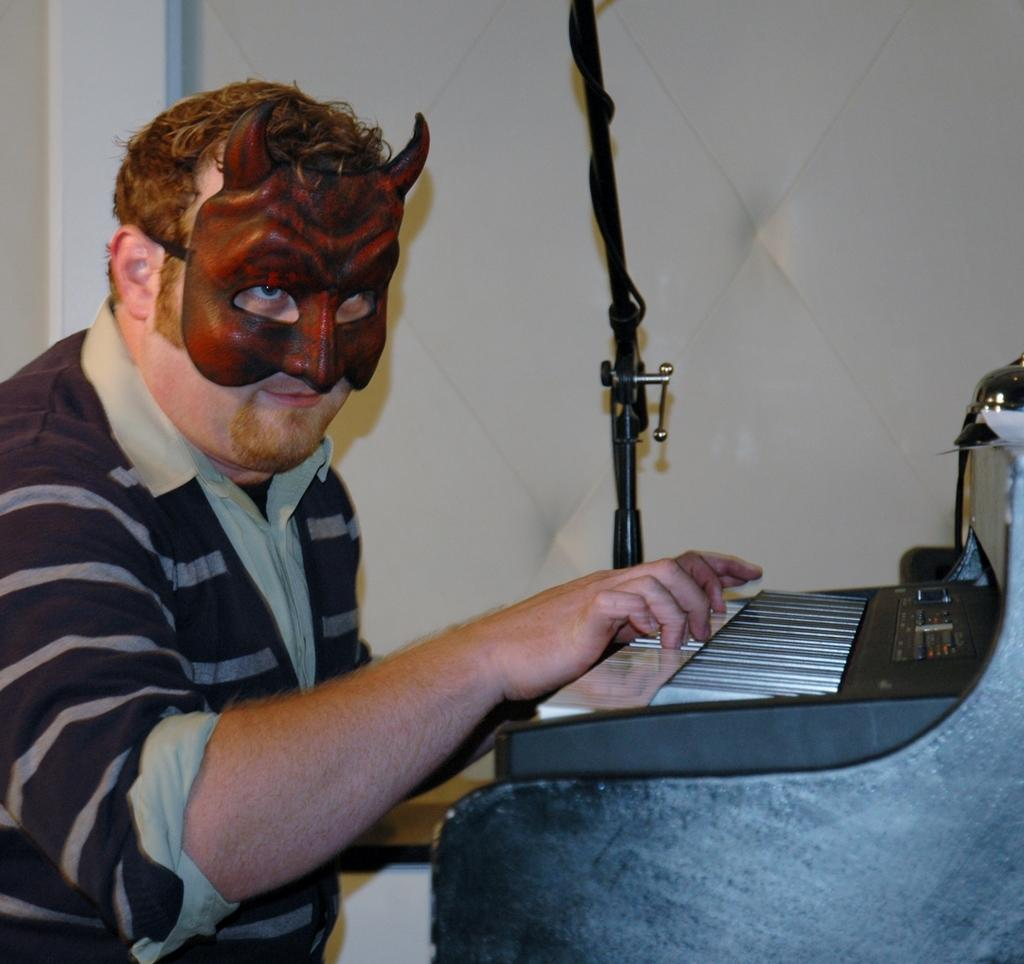What is the man in the image doing? The man is sitting and playing a piano in the image. What is the man wearing on his face? The man is wearing a mask in the image. What can be seen in the background of the image? There is a wall and a rod in the background of the image. What is the man arguing about with the wall in the image? There is no argument present in the image, nor is there any indication that the man is interacting with the wall. 